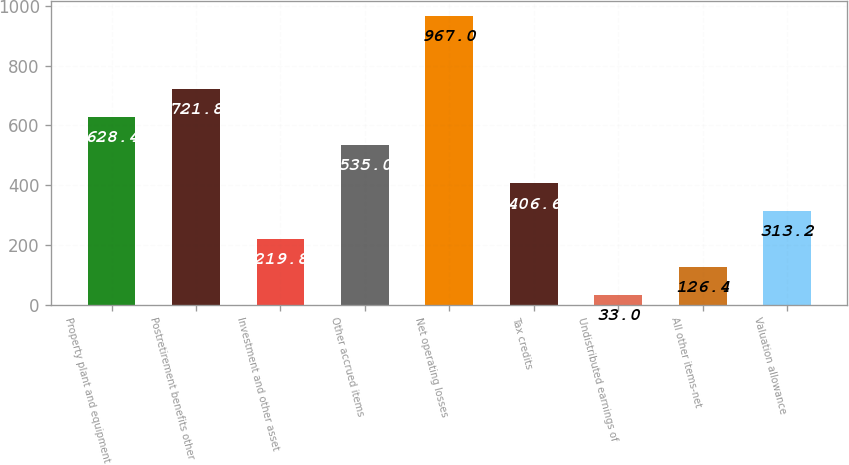Convert chart to OTSL. <chart><loc_0><loc_0><loc_500><loc_500><bar_chart><fcel>Property plant and equipment<fcel>Postretirement benefits other<fcel>Investment and other asset<fcel>Other accrued items<fcel>Net operating losses<fcel>Tax credits<fcel>Undistributed earnings of<fcel>All other items-net<fcel>Valuation allowance<nl><fcel>628.4<fcel>721.8<fcel>219.8<fcel>535<fcel>967<fcel>406.6<fcel>33<fcel>126.4<fcel>313.2<nl></chart> 